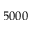<formula> <loc_0><loc_0><loc_500><loc_500>5 0 0 0</formula> 